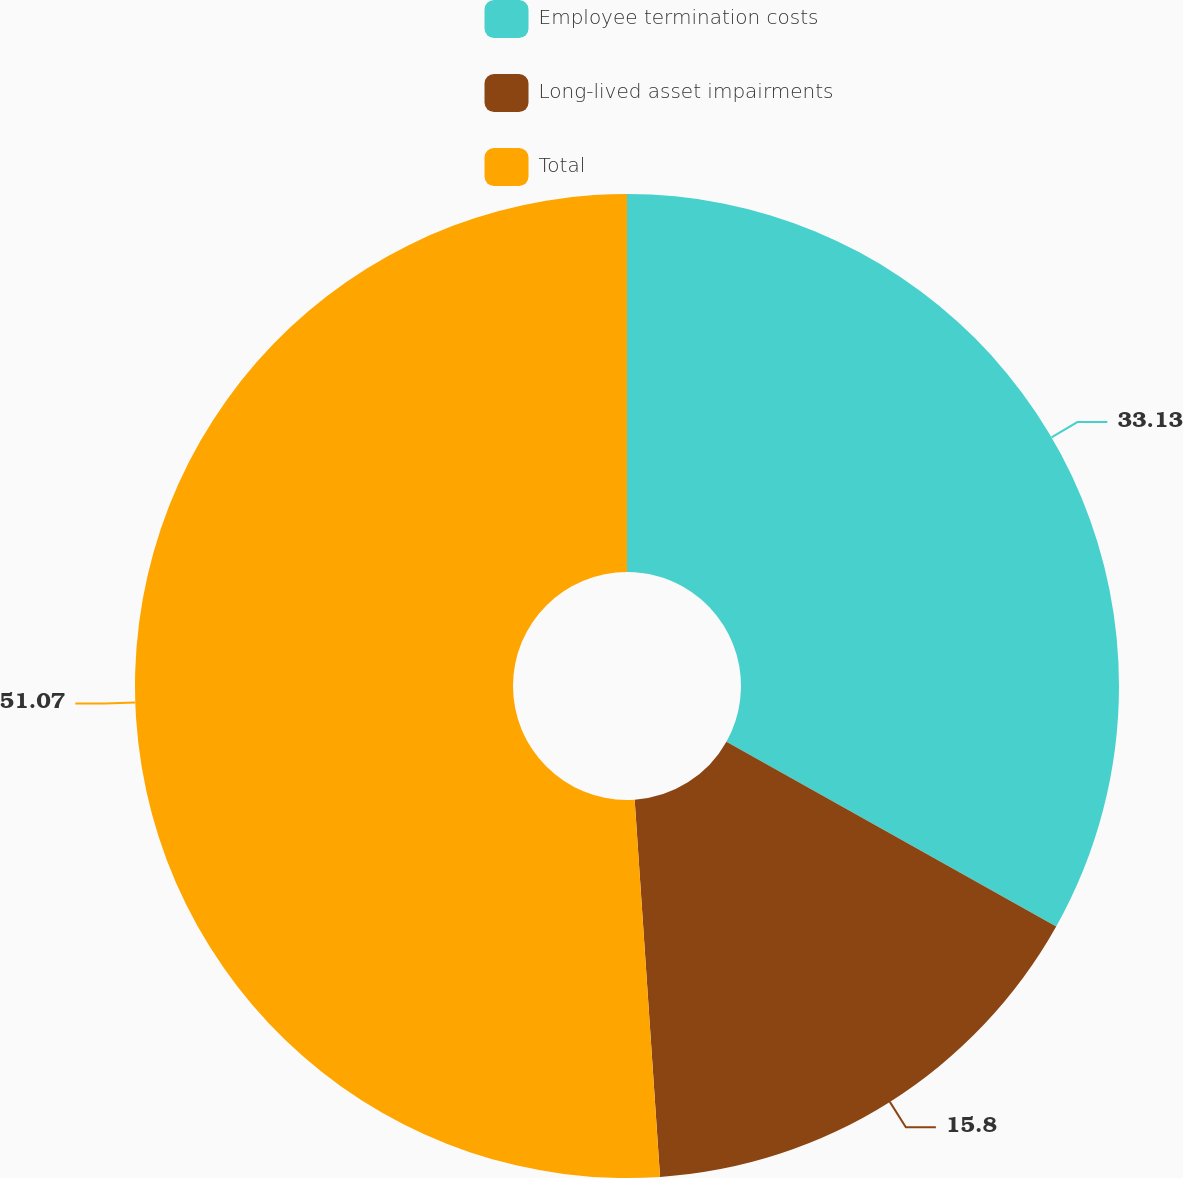<chart> <loc_0><loc_0><loc_500><loc_500><pie_chart><fcel>Employee termination costs<fcel>Long-lived asset impairments<fcel>Total<nl><fcel>33.13%<fcel>15.8%<fcel>51.07%<nl></chart> 